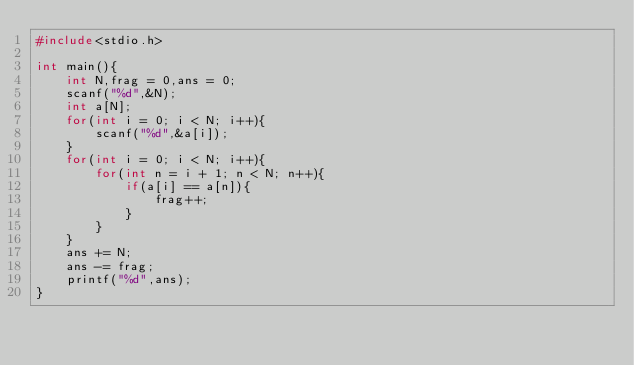<code> <loc_0><loc_0><loc_500><loc_500><_C_>#include<stdio.h>

int main(){
    int N,frag = 0,ans = 0;
    scanf("%d",&N);
    int a[N];
    for(int i = 0; i < N; i++){
        scanf("%d",&a[i]);
    }
    for(int i = 0; i < N; i++){
        for(int n = i + 1; n < N; n++){
            if(a[i] == a[n]){
                frag++;
            }
        }
    }
    ans += N;
    ans -= frag;
    printf("%d",ans);
}</code> 